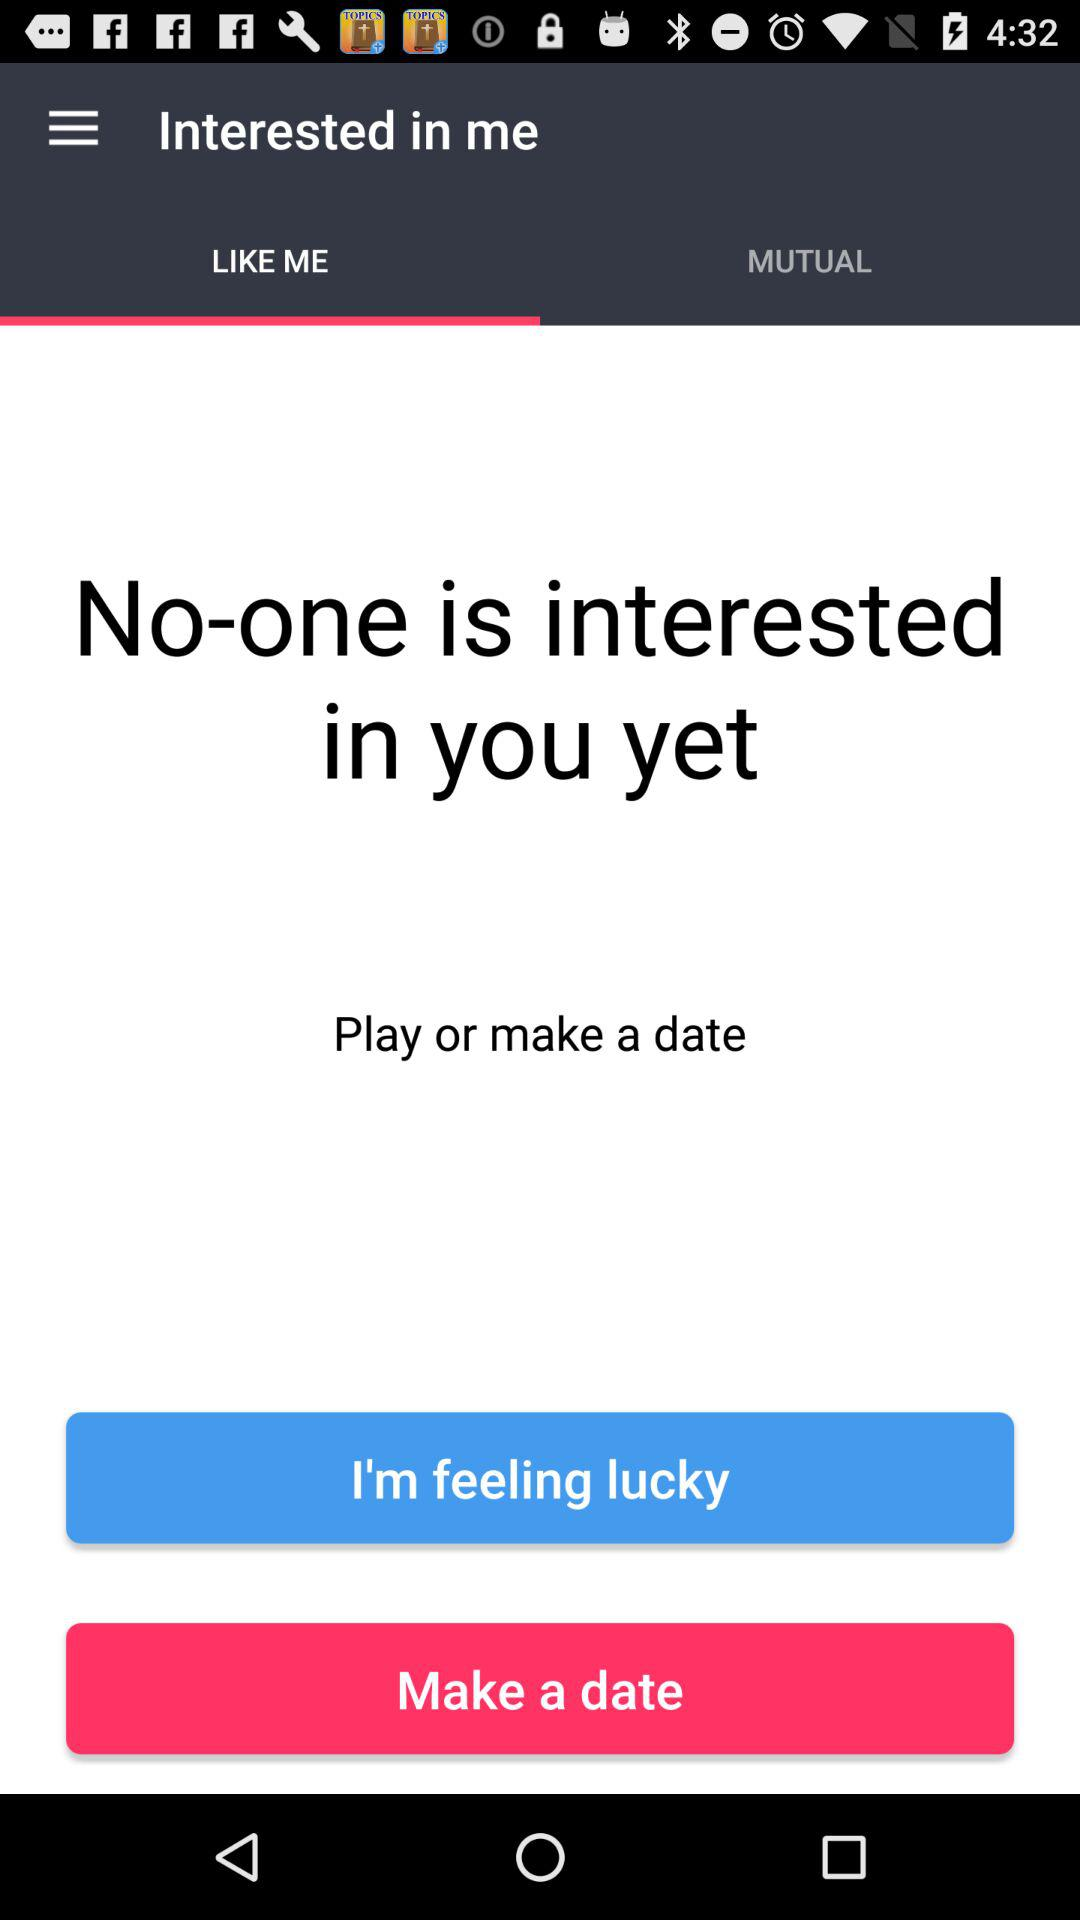Which tab is selected? The tab "LIKE ME" is selected. 